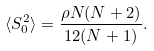Convert formula to latex. <formula><loc_0><loc_0><loc_500><loc_500>\langle S ^ { 2 } _ { 0 } \rangle = \frac { \rho N ( N + 2 ) } { 1 2 ( N + 1 ) } .</formula> 